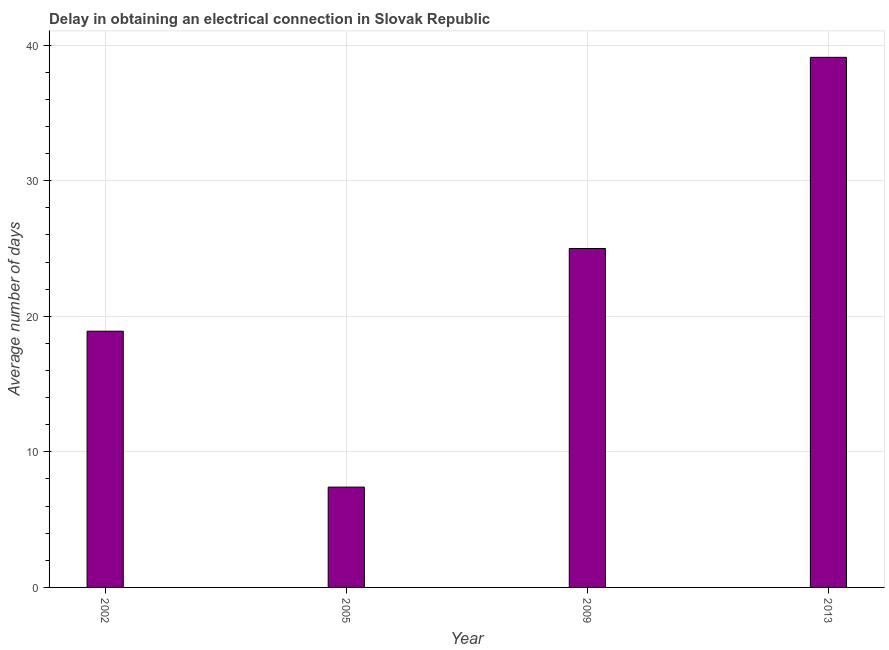What is the title of the graph?
Offer a very short reply. Delay in obtaining an electrical connection in Slovak Republic. What is the label or title of the X-axis?
Offer a very short reply. Year. What is the label or title of the Y-axis?
Make the answer very short. Average number of days. What is the dalay in electrical connection in 2005?
Your response must be concise. 7.4. Across all years, what is the maximum dalay in electrical connection?
Give a very brief answer. 39.1. In which year was the dalay in electrical connection maximum?
Ensure brevity in your answer.  2013. What is the sum of the dalay in electrical connection?
Keep it short and to the point. 90.4. What is the difference between the dalay in electrical connection in 2005 and 2013?
Your answer should be compact. -31.7. What is the average dalay in electrical connection per year?
Offer a very short reply. 22.6. What is the median dalay in electrical connection?
Your response must be concise. 21.95. In how many years, is the dalay in electrical connection greater than 2 days?
Ensure brevity in your answer.  4. What is the ratio of the dalay in electrical connection in 2009 to that in 2013?
Your response must be concise. 0.64. What is the difference between the highest and the second highest dalay in electrical connection?
Keep it short and to the point. 14.1. What is the difference between the highest and the lowest dalay in electrical connection?
Your response must be concise. 31.7. In how many years, is the dalay in electrical connection greater than the average dalay in electrical connection taken over all years?
Provide a succinct answer. 2. How many bars are there?
Offer a terse response. 4. Are all the bars in the graph horizontal?
Offer a very short reply. No. How many years are there in the graph?
Offer a terse response. 4. Are the values on the major ticks of Y-axis written in scientific E-notation?
Give a very brief answer. No. What is the Average number of days of 2005?
Offer a terse response. 7.4. What is the Average number of days of 2009?
Offer a terse response. 25. What is the Average number of days of 2013?
Offer a terse response. 39.1. What is the difference between the Average number of days in 2002 and 2005?
Your response must be concise. 11.5. What is the difference between the Average number of days in 2002 and 2013?
Ensure brevity in your answer.  -20.2. What is the difference between the Average number of days in 2005 and 2009?
Offer a terse response. -17.6. What is the difference between the Average number of days in 2005 and 2013?
Your answer should be compact. -31.7. What is the difference between the Average number of days in 2009 and 2013?
Provide a succinct answer. -14.1. What is the ratio of the Average number of days in 2002 to that in 2005?
Your answer should be very brief. 2.55. What is the ratio of the Average number of days in 2002 to that in 2009?
Ensure brevity in your answer.  0.76. What is the ratio of the Average number of days in 2002 to that in 2013?
Your response must be concise. 0.48. What is the ratio of the Average number of days in 2005 to that in 2009?
Give a very brief answer. 0.3. What is the ratio of the Average number of days in 2005 to that in 2013?
Keep it short and to the point. 0.19. What is the ratio of the Average number of days in 2009 to that in 2013?
Your response must be concise. 0.64. 